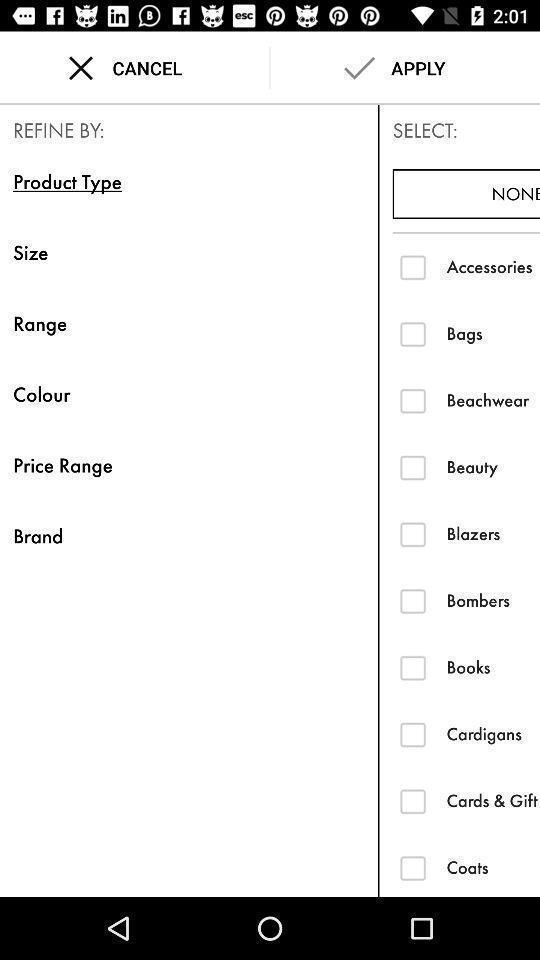Give me a narrative description of this picture. Page to select product details in the shopping app. 